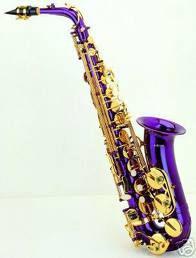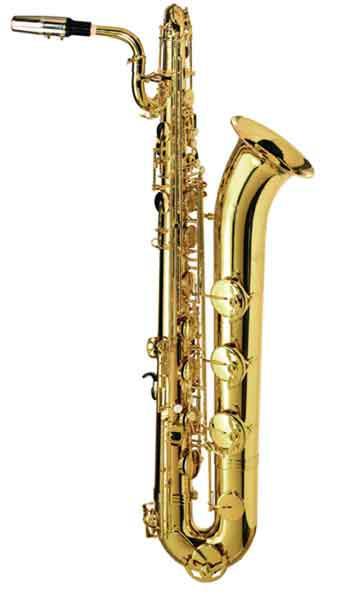The first image is the image on the left, the second image is the image on the right. Examine the images to the left and right. Is the description "In at least one image that is a golden brass saxophone  with a black and gold mouth pieces." accurate? Answer yes or no. No. The first image is the image on the left, the second image is the image on the right. Analyze the images presented: Is the assertion "Each image shows one upright gold colored saxophone with its bell facing rightward and its black-tipped mouthpiece facing leftward." valid? Answer yes or no. No. 